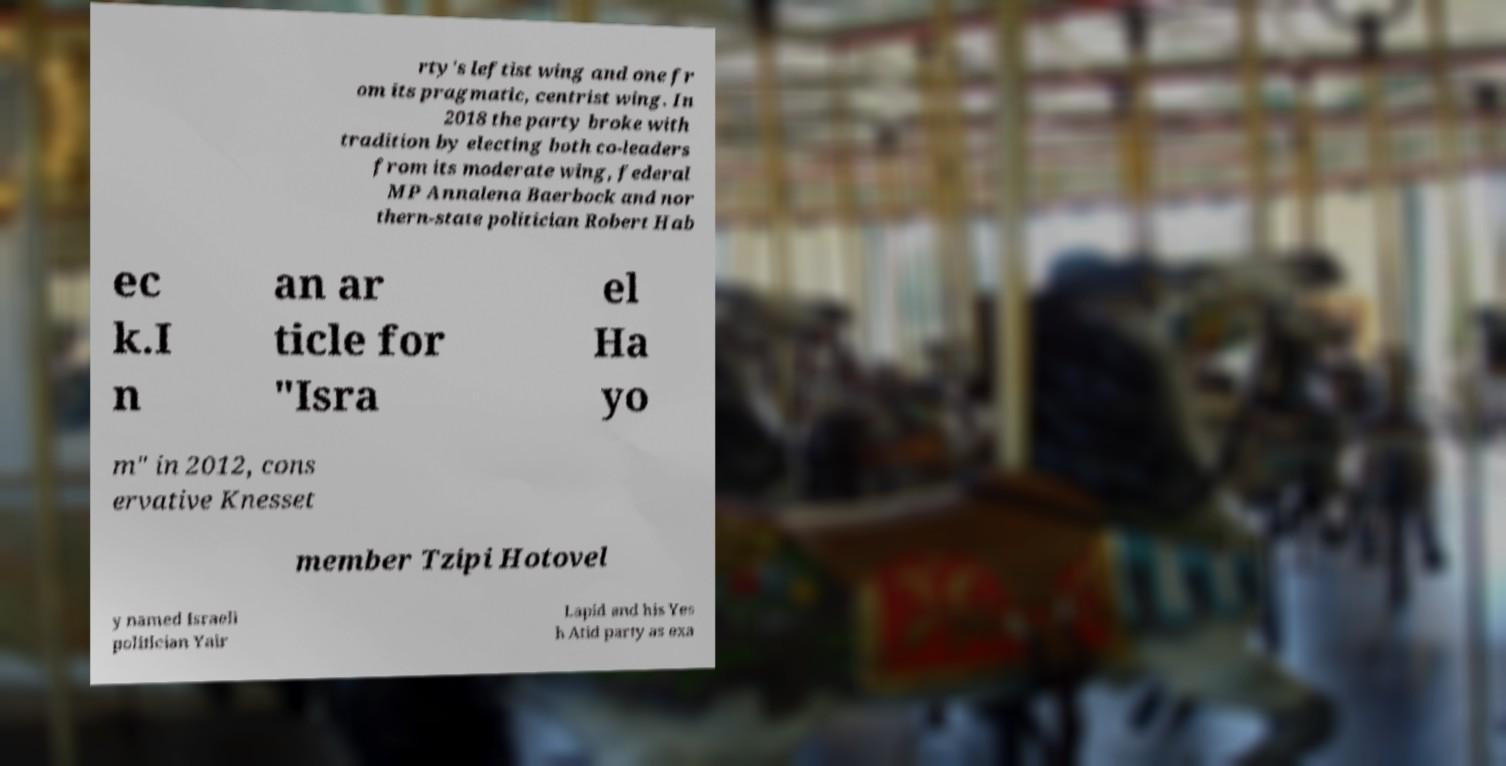I need the written content from this picture converted into text. Can you do that? rty's leftist wing and one fr om its pragmatic, centrist wing. In 2018 the party broke with tradition by electing both co-leaders from its moderate wing, federal MP Annalena Baerbock and nor thern-state politician Robert Hab ec k.I n an ar ticle for "Isra el Ha yo m" in 2012, cons ervative Knesset member Tzipi Hotovel y named Israeli politician Yair Lapid and his Yes h Atid party as exa 